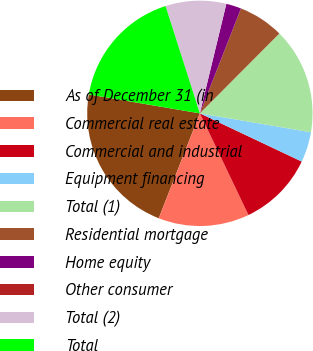Convert chart to OTSL. <chart><loc_0><loc_0><loc_500><loc_500><pie_chart><fcel>As of December 31 (in<fcel>Commercial real estate<fcel>Commercial and industrial<fcel>Equipment financing<fcel>Total (1)<fcel>Residential mortgage<fcel>Home equity<fcel>Other consumer<fcel>Total (2)<fcel>Total<nl><fcel>21.74%<fcel>13.04%<fcel>10.87%<fcel>4.35%<fcel>15.22%<fcel>6.52%<fcel>2.17%<fcel>0.0%<fcel>8.7%<fcel>17.39%<nl></chart> 